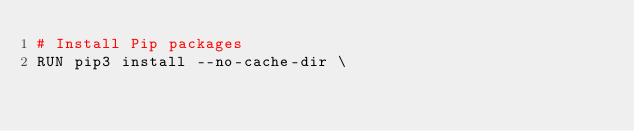<code> <loc_0><loc_0><loc_500><loc_500><_Dockerfile_># Install Pip packages
RUN pip3 install --no-cache-dir \</code> 